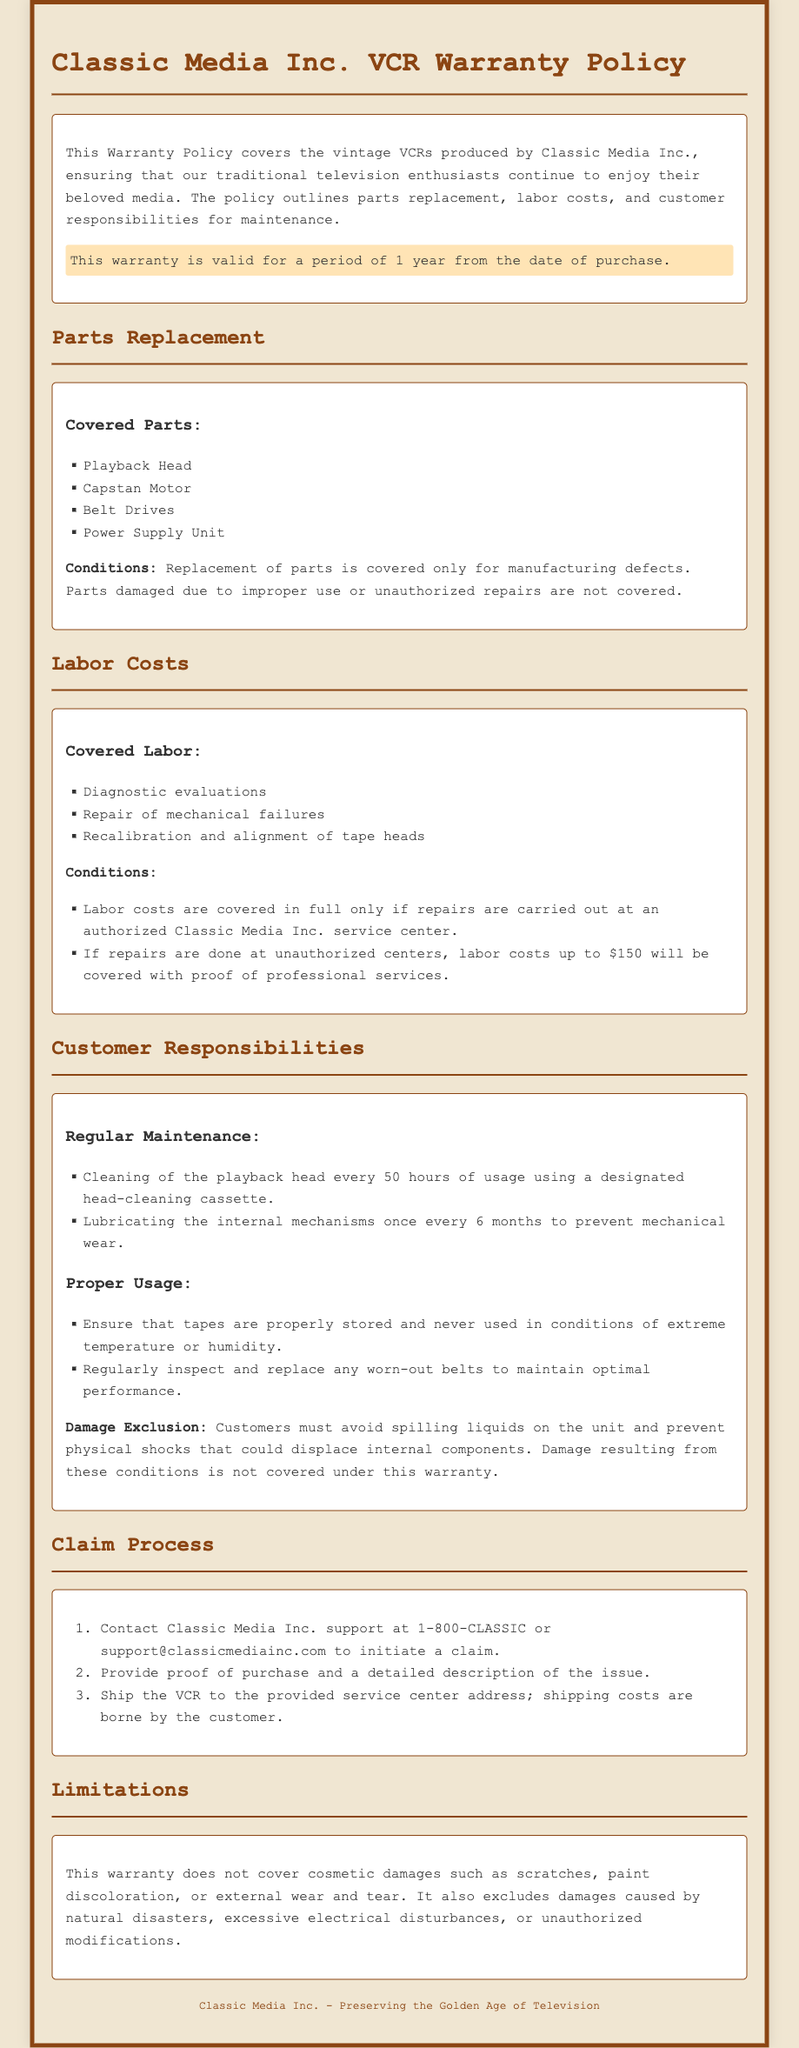What is the warranty period? The warranty is valid for one year from the date of purchase as stated in the document.
Answer: 1 year What parts are covered under the warranty? The document lists specific parts that are covered, which include the Playback Head, Capstan Motor, Belt Drives, and Power Supply Unit.
Answer: Playback Head, Capstan Motor, Belt Drives, Power Supply Unit What costs are covered for unauthorized repairs? The warranty outlines specific conditions for labor cost coverage when repairs are done at unauthorized centers. Up to a specified amount is covered.
Answer: $150 What is a customer responsibility for maintenance? The document details several customer responsibilities, one of which is to clean the playback head regularly using a specific method.
Answer: Cleaning of the playback head How should customers initiate a warranty claim? The claim process begins with contacting Classic Media Inc. support, which is clearly outlined in the document.
Answer: Contact support What type of damages are not covered by the warranty? The document explicitly mentions certain types of damage that are excluded from the warranty coverage, including cosmetic damages.
Answer: Cosmetic damages How often should the internal mechanisms be lubricated? Regular maintenance includes specific tasks that should be performed at defined intervals, which is mentioned in the document.
Answer: Once every 6 months Which type of service center must repairs take place in for full labor cost coverage? The warranty specifies the type of service center where repairs must be conducted to cover labor costs fully.
Answer: Authorized Classic Media Inc. service center What must customers provide when making a claim? The document states that customers need to provide specific information to initiate a claim, which includes proof of purchase.
Answer: Proof of purchase 